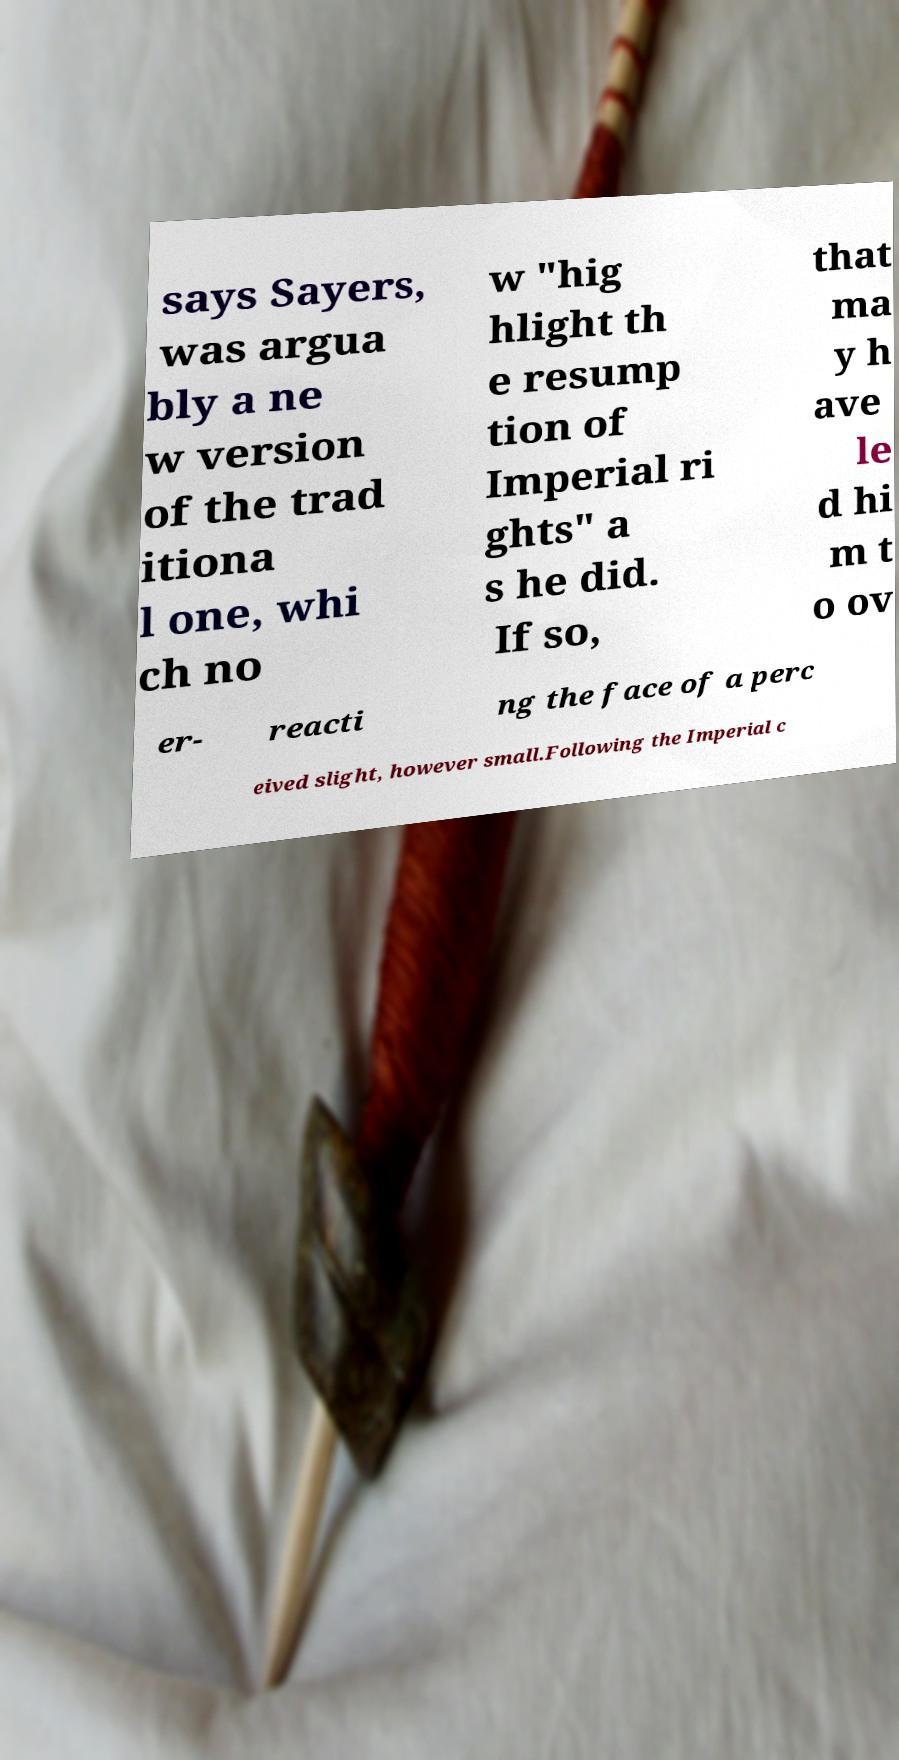I need the written content from this picture converted into text. Can you do that? says Sayers, was argua bly a ne w version of the trad itiona l one, whi ch no w "hig hlight th e resump tion of Imperial ri ghts" a s he did. If so, that ma y h ave le d hi m t o ov er- reacti ng the face of a perc eived slight, however small.Following the Imperial c 